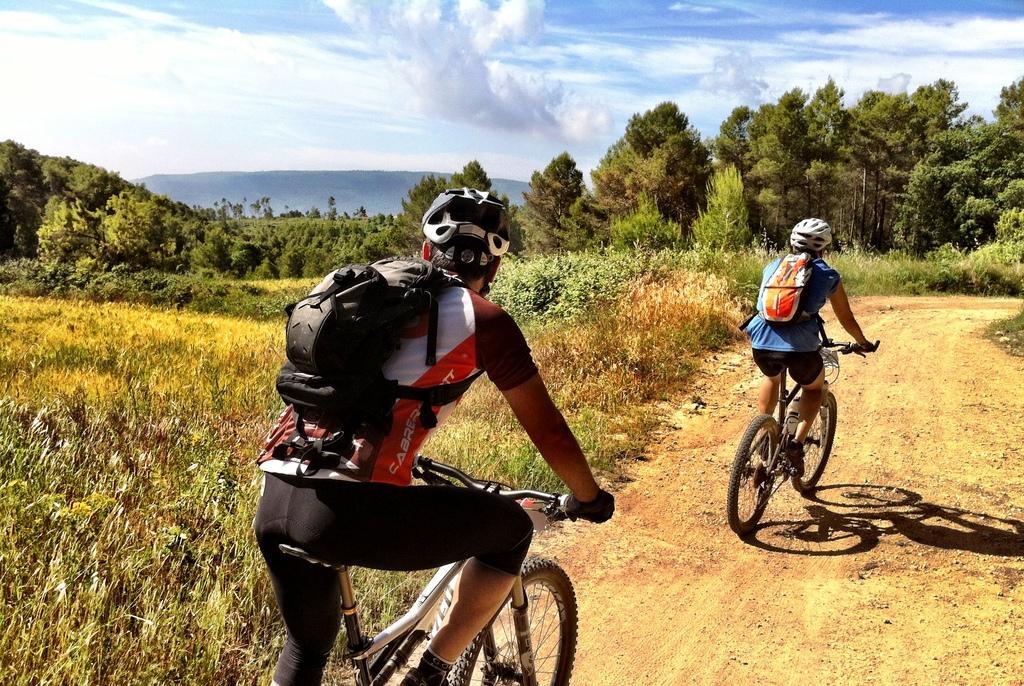In one or two sentences, can you explain what this image depicts? This picture shows two men riding bicycle and we see a blue cloudy sky and trees around 